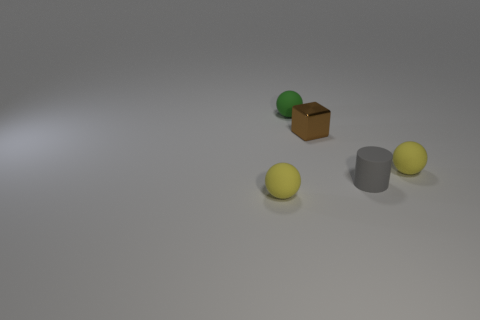Subtract all yellow rubber spheres. How many spheres are left? 1 Subtract all green blocks. How many yellow spheres are left? 2 Add 3 green cylinders. How many objects exist? 8 Subtract all green spheres. How many spheres are left? 2 Subtract 1 balls. How many balls are left? 2 Subtract all cylinders. How many objects are left? 4 Subtract all brown shiny objects. Subtract all red matte cylinders. How many objects are left? 4 Add 5 tiny matte cylinders. How many tiny matte cylinders are left? 6 Add 4 green balls. How many green balls exist? 5 Subtract 0 cyan cylinders. How many objects are left? 5 